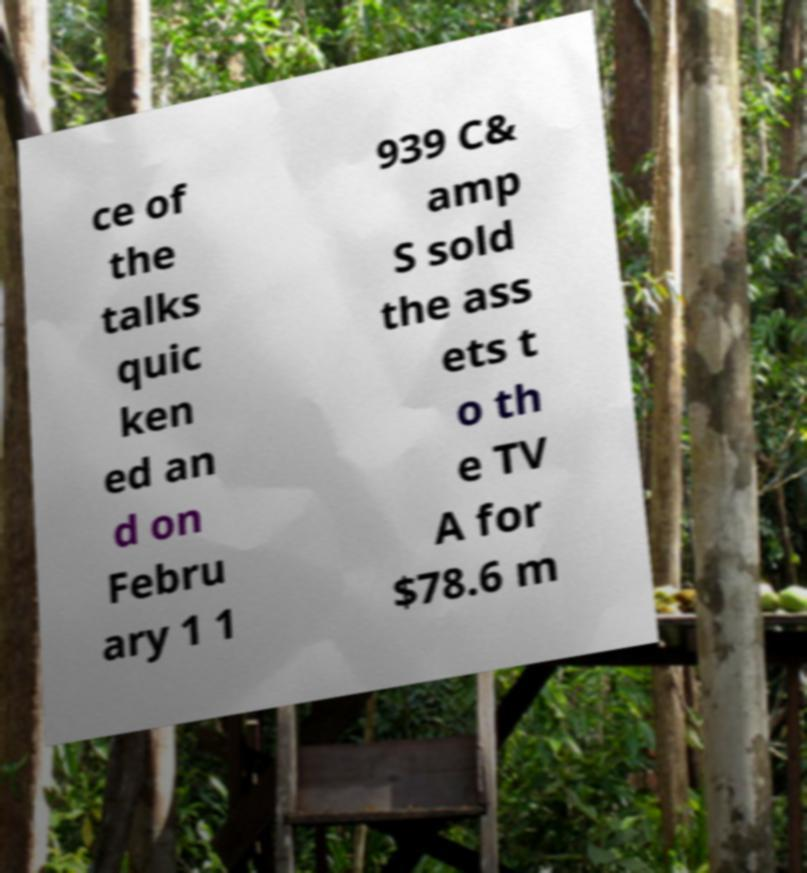For documentation purposes, I need the text within this image transcribed. Could you provide that? ce of the talks quic ken ed an d on Febru ary 1 1 939 C& amp S sold the ass ets t o th e TV A for $78.6 m 